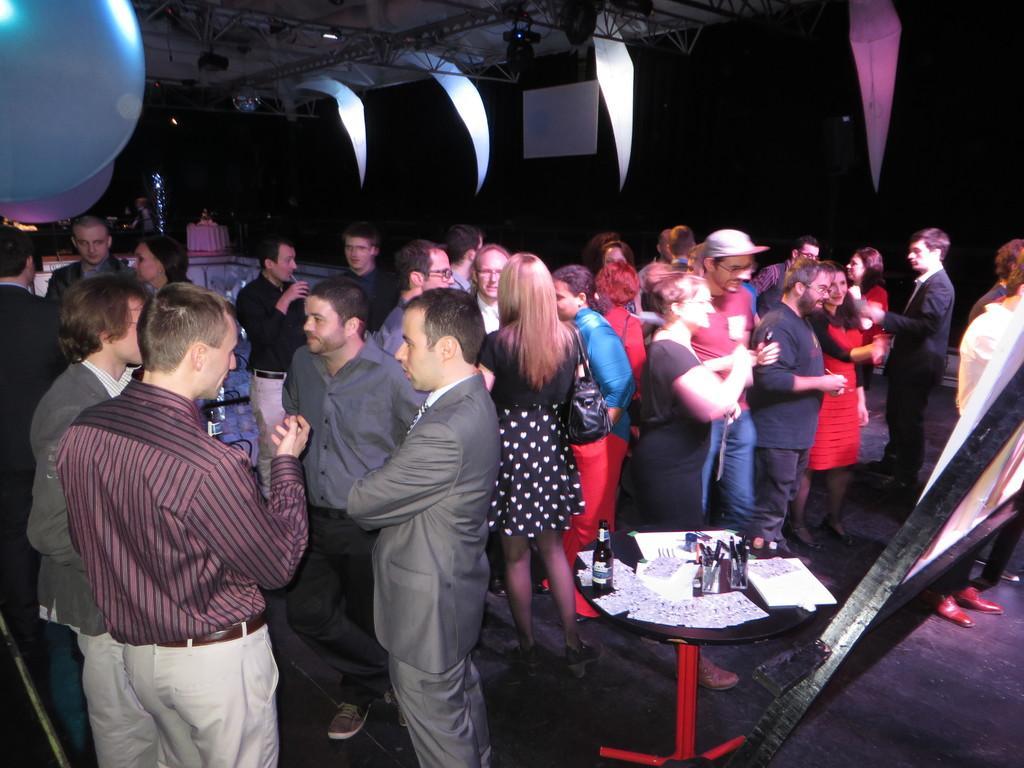Could you give a brief overview of what you see in this image? In this picture there is a group of men and women, standing in the hall and discussing something. Beside there is a black table with beer bottle and papers. On the top we can see the black color frame and shed. 